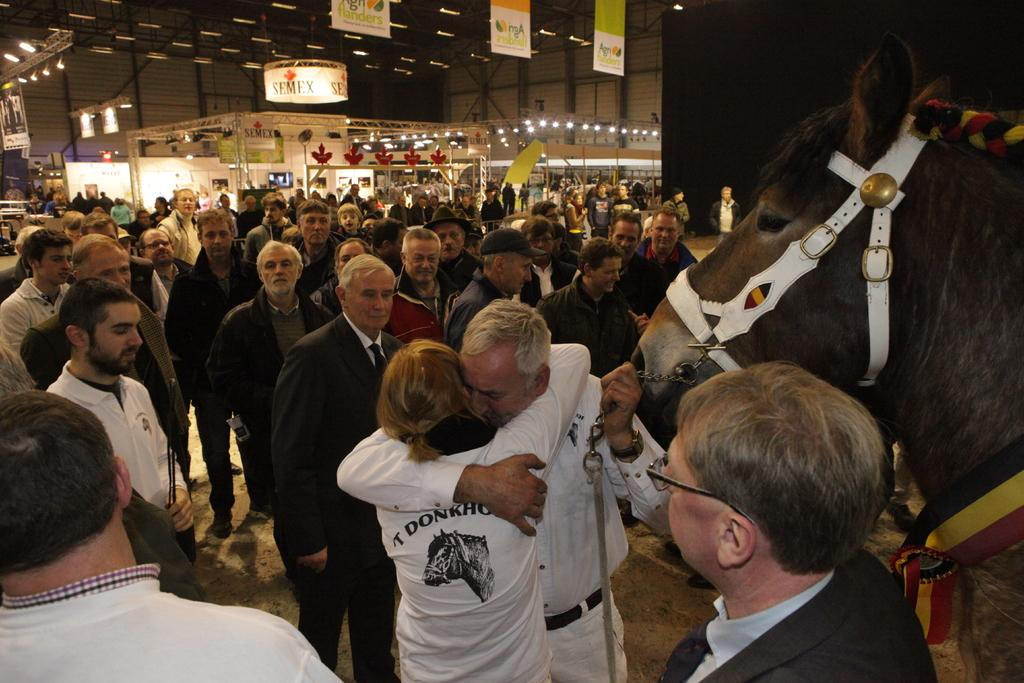What is happening in the image? There are people standing in the image. What can be seen hanging or displayed in the image? There is a banner in the image. What type of structure is present in the image? There is a wall in the image. Where is the lamp located in the image? There is no lamp present in the image. What type of arch can be seen in the image? There is no arch present in the image. 